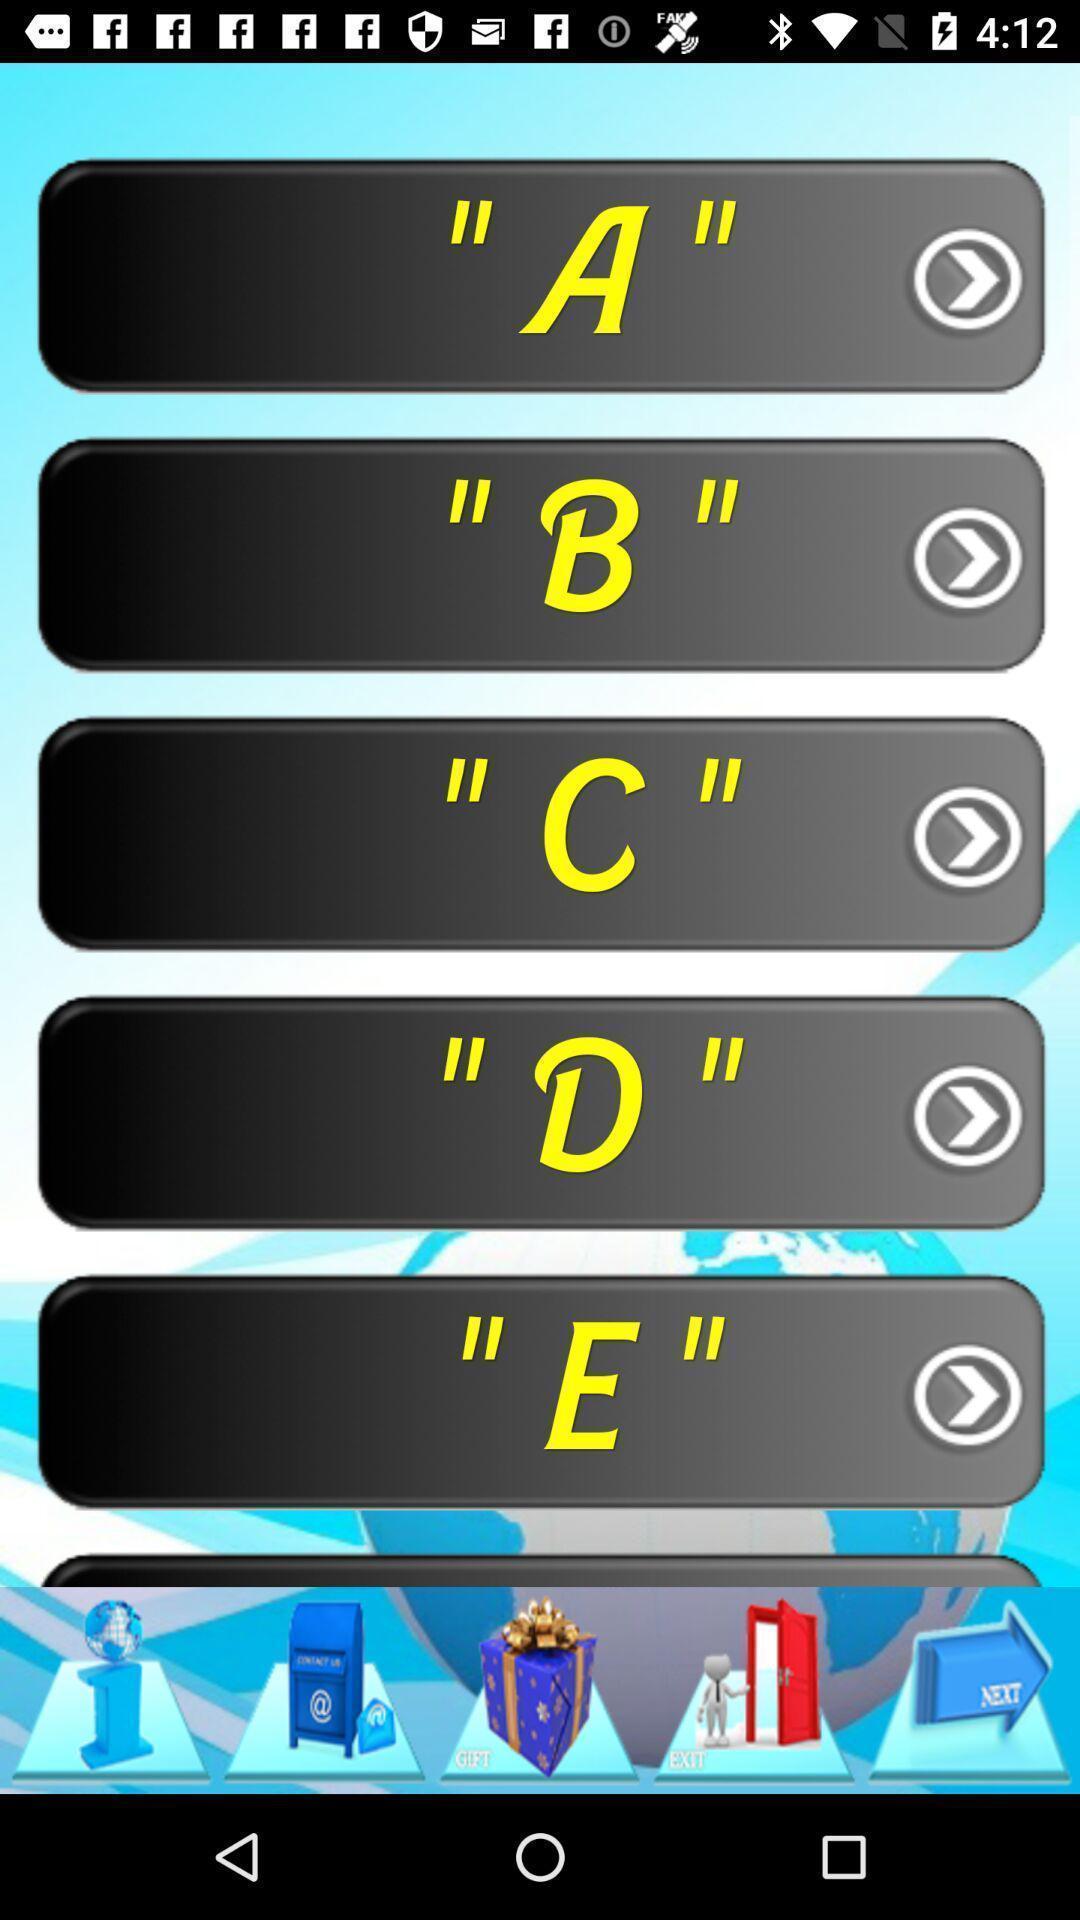Give me a summary of this screen capture. Various alphabetical letters displayed. 